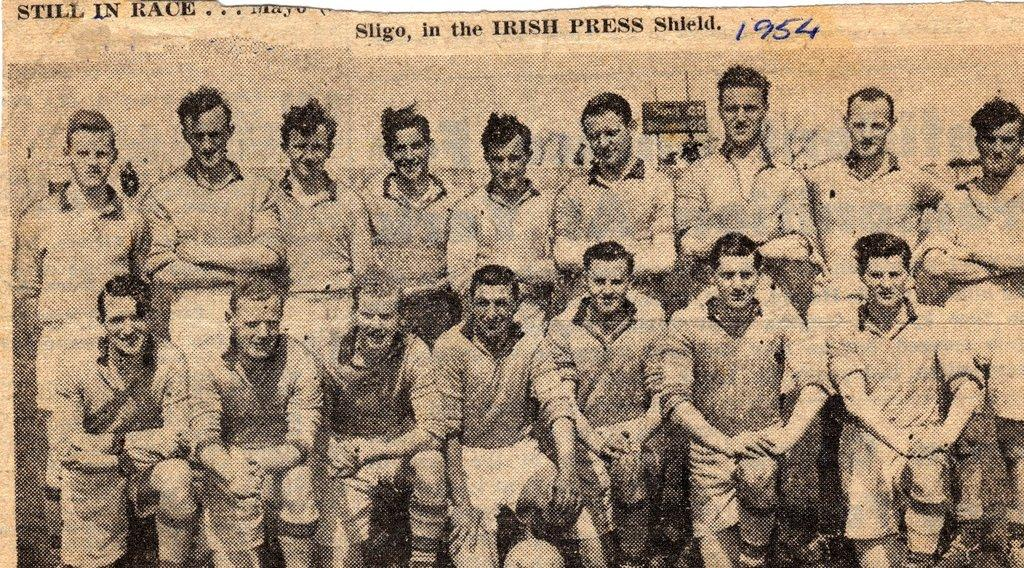How many people are in the image? There is a group of people in the image, but the exact number cannot be determined from the provided facts. What can be seen in the background of the image? There is a board in the background of the image. What is written on the board? Something is written on the board, but the specific content cannot be determined from the provided facts. Can you tell me how many umbrellas are being used by the people in the image? There is no mention of umbrellas in the provided facts, so we cannot determine if any umbrellas are present in the image. What type of ink is used to write on the board in the image? The type of ink used to write on the board cannot be determined from the provided facts. 